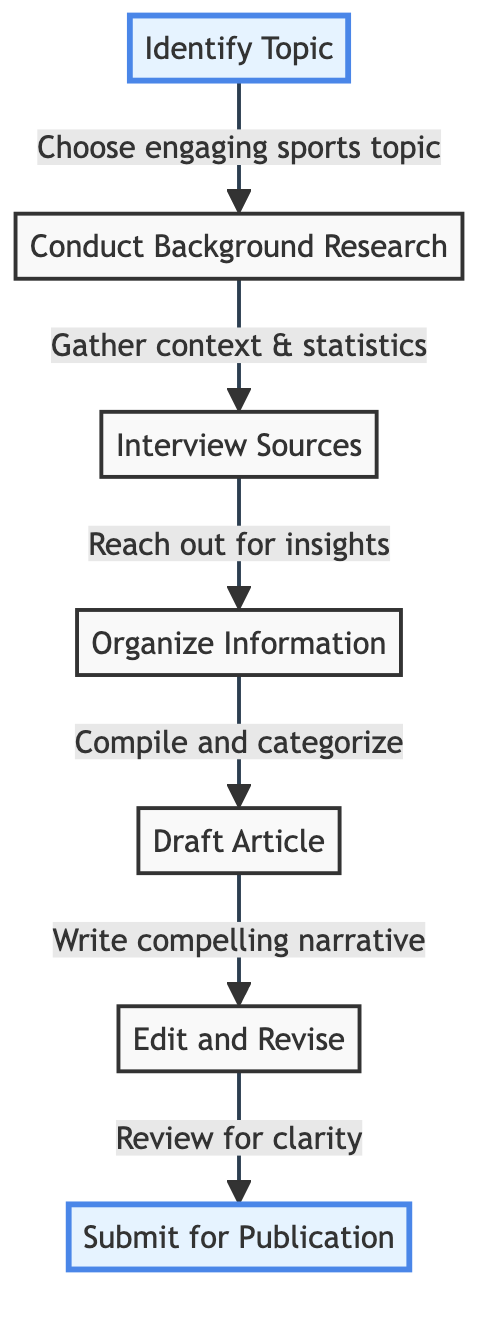What is the first step in the process? The first step is labeled "Identify Topic," which is indicated at the top of the flow chart.
Answer: Identify Topic How many steps are in the process? Counting all the steps listed in the diagram, there are seven distinct steps from identifying the topic to submitting for publication.
Answer: 7 What follows "Conduct Background Research"? After "Conduct Background Research," the next step in the flow chart is "Interview Sources," as indicated by the arrow leading from one node to the next.
Answer: Interview Sources What is the last step before submission? The last step before submission is "Edit and Revise," which comes immediately before the final step of submitting for publication.
Answer: Edit and Revise What connects "Draft Article" and "Edit and Revise"? The connection between "Draft Article" and "Edit and Revise" is an arrow indicating a direct progression from drafting to the editing process.
Answer: Arrow How many nodes are direct predecessors of "Draft Article"? "Draft Article" has two direct predecessors, which are "Organize Information" and "Interview Sources," leading to this step.
Answer: 2 What is the focus of the "Conduct Background Research" step? The focus of this step is to "Gather context & statistics," as clearly stated in the description associated with that node.
Answer: Gather context & statistics What is the significance of the highlighted nodes? The highlighted nodes indicate the starting point and the endpoint of the entire process, showing where the process begins and concludes.
Answer: Starting and endpoint What type of information do you collect in "Organize Information"? In "Organize Information," the collected data is "Compiled and categorized," focusing on structuring the information gathered prior to the drafting stage.
Answer: Compiled and categorized 